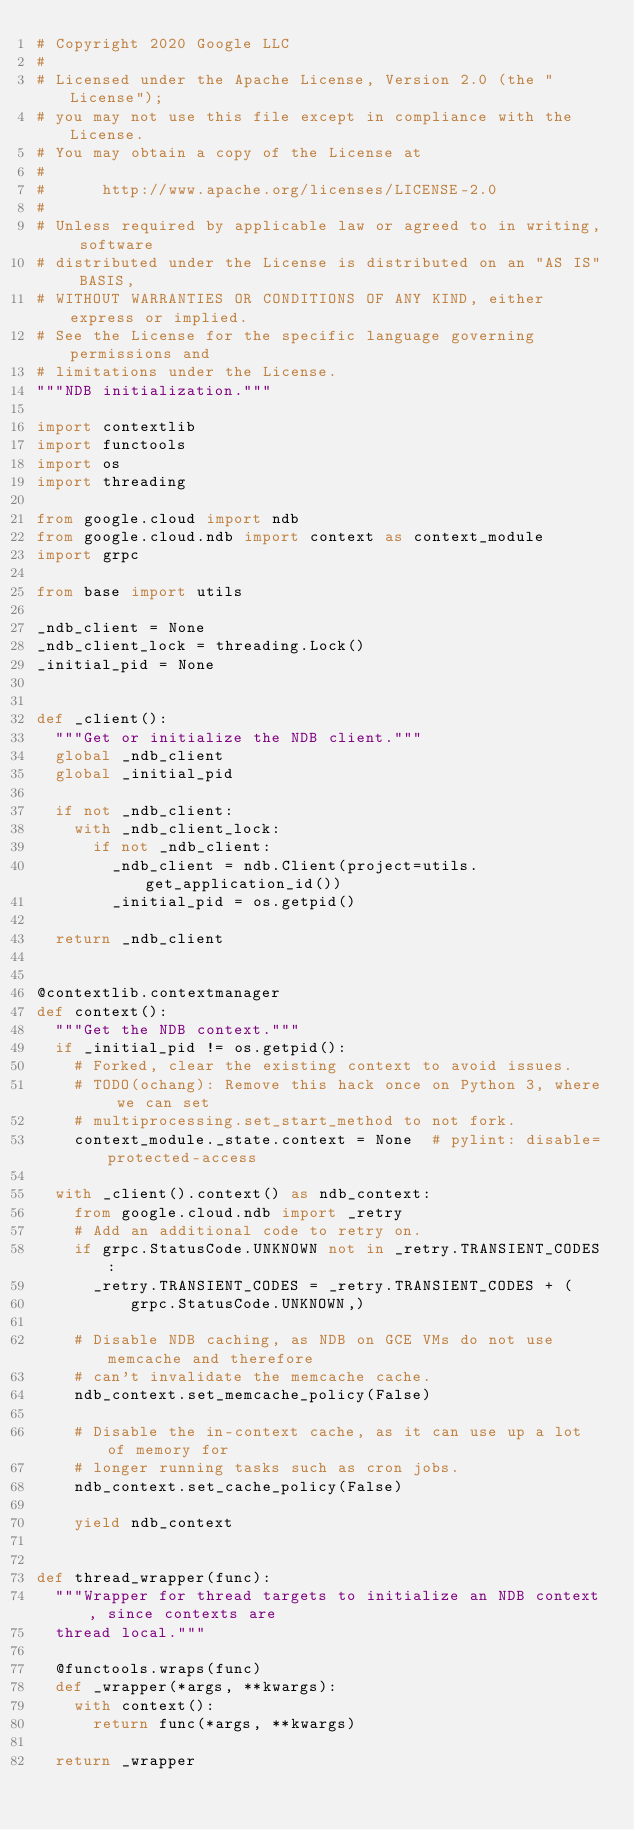Convert code to text. <code><loc_0><loc_0><loc_500><loc_500><_Python_># Copyright 2020 Google LLC
#
# Licensed under the Apache License, Version 2.0 (the "License");
# you may not use this file except in compliance with the License.
# You may obtain a copy of the License at
#
#      http://www.apache.org/licenses/LICENSE-2.0
#
# Unless required by applicable law or agreed to in writing, software
# distributed under the License is distributed on an "AS IS" BASIS,
# WITHOUT WARRANTIES OR CONDITIONS OF ANY KIND, either express or implied.
# See the License for the specific language governing permissions and
# limitations under the License.
"""NDB initialization."""

import contextlib
import functools
import os
import threading

from google.cloud import ndb
from google.cloud.ndb import context as context_module
import grpc

from base import utils

_ndb_client = None
_ndb_client_lock = threading.Lock()
_initial_pid = None


def _client():
  """Get or initialize the NDB client."""
  global _ndb_client
  global _initial_pid

  if not _ndb_client:
    with _ndb_client_lock:
      if not _ndb_client:
        _ndb_client = ndb.Client(project=utils.get_application_id())
        _initial_pid = os.getpid()

  return _ndb_client


@contextlib.contextmanager
def context():
  """Get the NDB context."""
  if _initial_pid != os.getpid():
    # Forked, clear the existing context to avoid issues.
    # TODO(ochang): Remove this hack once on Python 3, where we can set
    # multiprocessing.set_start_method to not fork.
    context_module._state.context = None  # pylint: disable=protected-access

  with _client().context() as ndb_context:
    from google.cloud.ndb import _retry
    # Add an additional code to retry on.
    if grpc.StatusCode.UNKNOWN not in _retry.TRANSIENT_CODES:
      _retry.TRANSIENT_CODES = _retry.TRANSIENT_CODES + (
          grpc.StatusCode.UNKNOWN,)

    # Disable NDB caching, as NDB on GCE VMs do not use memcache and therefore
    # can't invalidate the memcache cache.
    ndb_context.set_memcache_policy(False)

    # Disable the in-context cache, as it can use up a lot of memory for
    # longer running tasks such as cron jobs.
    ndb_context.set_cache_policy(False)

    yield ndb_context


def thread_wrapper(func):
  """Wrapper for thread targets to initialize an NDB context, since contexts are
  thread local."""

  @functools.wraps(func)
  def _wrapper(*args, **kwargs):
    with context():
      return func(*args, **kwargs)

  return _wrapper
</code> 